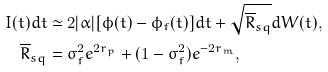Convert formula to latex. <formula><loc_0><loc_0><loc_500><loc_500>I ( t ) d t & \simeq 2 | \alpha | [ \phi ( t ) - \phi _ { f } ( t ) ] d t + \sqrt { \overline { R } _ { s q } } d W ( t ) , \\ \overline { R } _ { s q } & = \sigma _ { f } ^ { 2 } e ^ { 2 r _ { p } } + ( 1 - \sigma _ { f } ^ { 2 } ) e ^ { - 2 r _ { m } } ,</formula> 